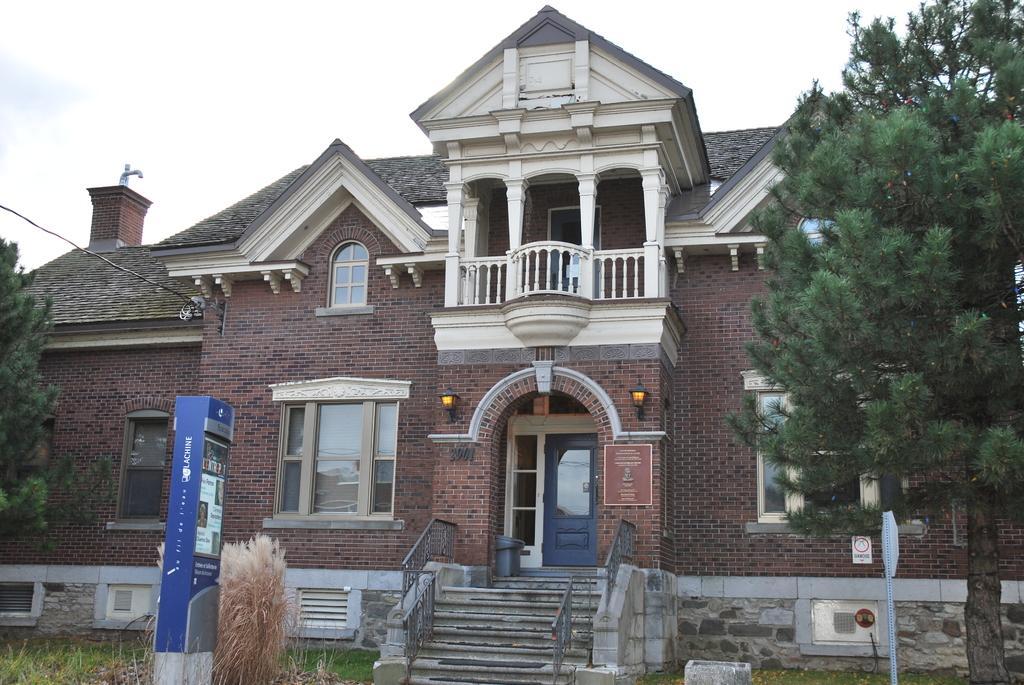How would you summarize this image in a sentence or two? Here at the bottom we can see grass,poles and an object. In the background there is a building,windows,doors,lights,two boards on the wall,electric wire on the left side,trees and clouds in the sky. 